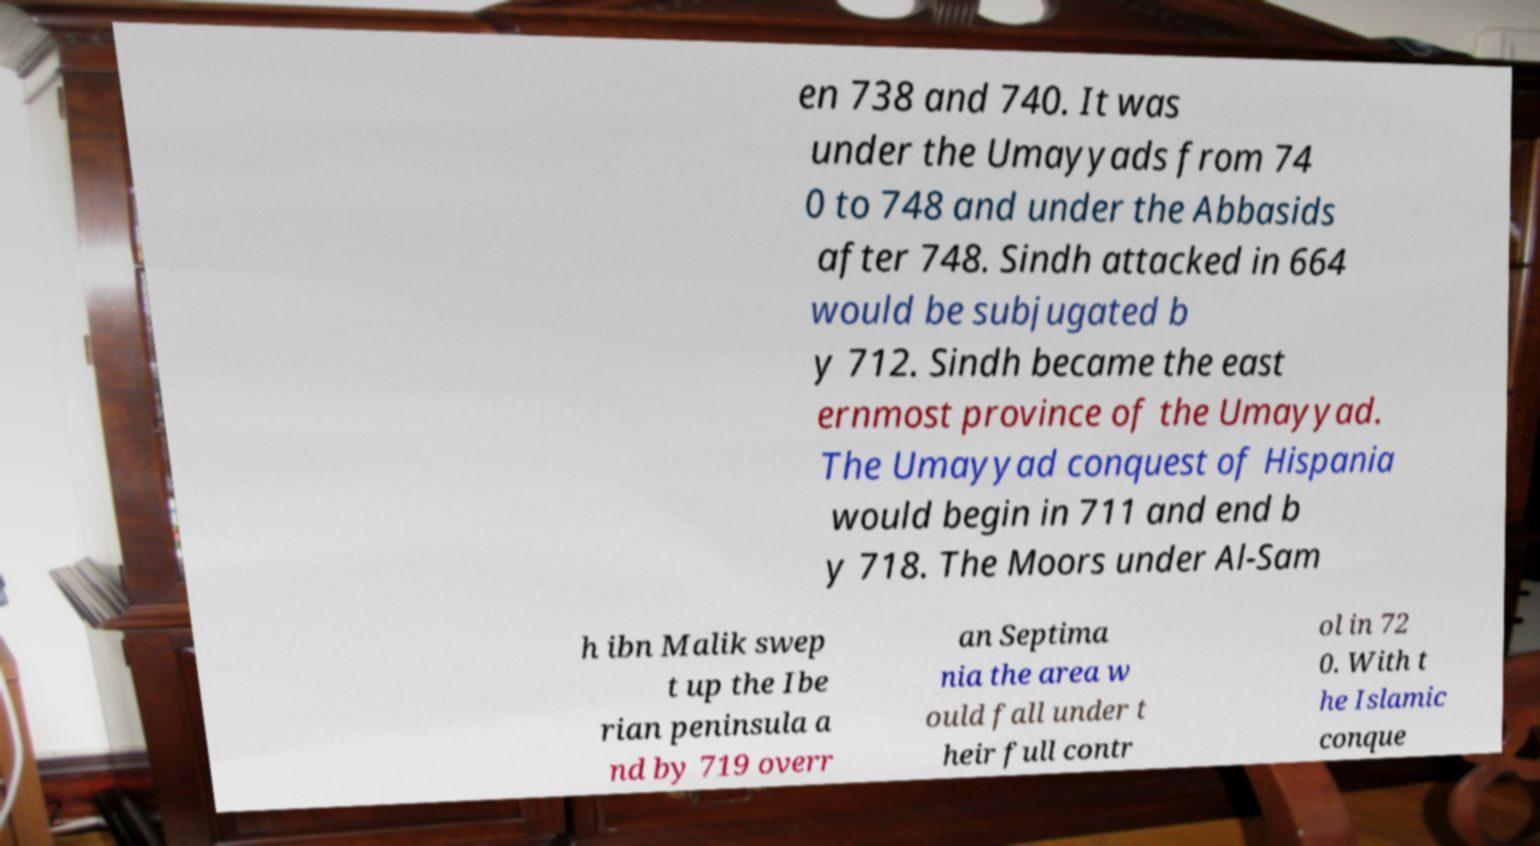For documentation purposes, I need the text within this image transcribed. Could you provide that? en 738 and 740. It was under the Umayyads from 74 0 to 748 and under the Abbasids after 748. Sindh attacked in 664 would be subjugated b y 712. Sindh became the east ernmost province of the Umayyad. The Umayyad conquest of Hispania would begin in 711 and end b y 718. The Moors under Al-Sam h ibn Malik swep t up the Ibe rian peninsula a nd by 719 overr an Septima nia the area w ould fall under t heir full contr ol in 72 0. With t he Islamic conque 